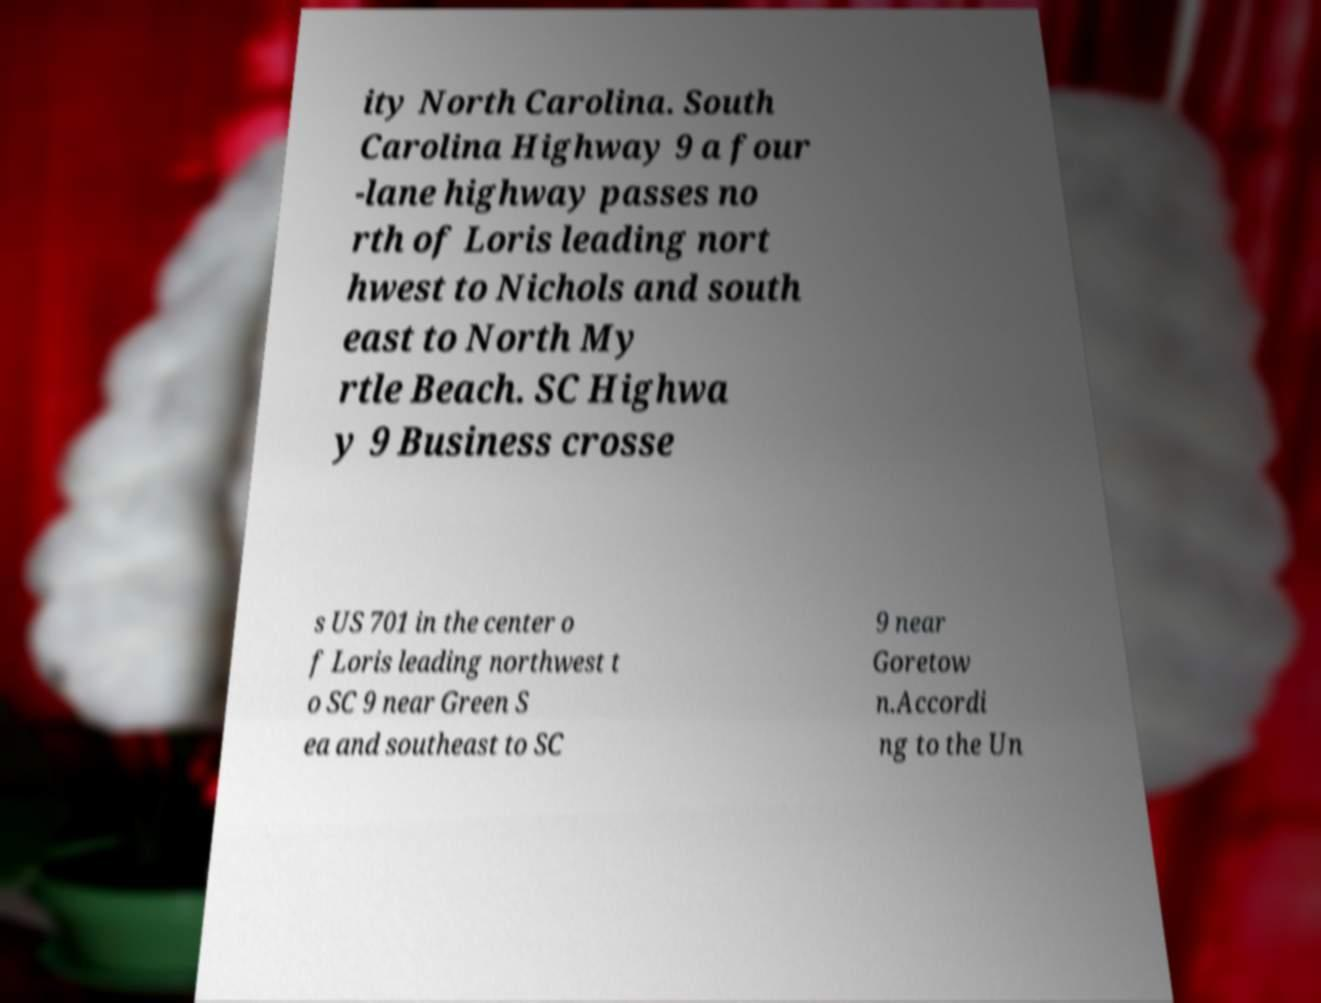For documentation purposes, I need the text within this image transcribed. Could you provide that? ity North Carolina. South Carolina Highway 9 a four -lane highway passes no rth of Loris leading nort hwest to Nichols and south east to North My rtle Beach. SC Highwa y 9 Business crosse s US 701 in the center o f Loris leading northwest t o SC 9 near Green S ea and southeast to SC 9 near Goretow n.Accordi ng to the Un 